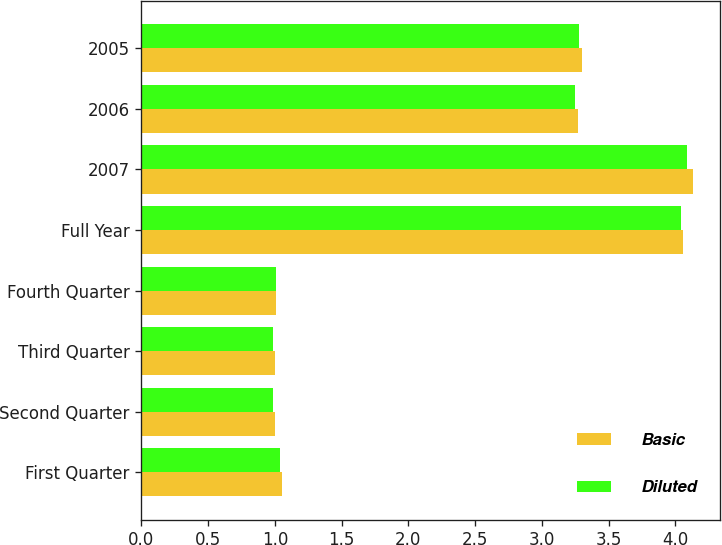<chart> <loc_0><loc_0><loc_500><loc_500><stacked_bar_chart><ecel><fcel>First Quarter<fcel>Second Quarter<fcel>Third Quarter<fcel>Fourth Quarter<fcel>Full Year<fcel>2007<fcel>2006<fcel>2005<nl><fcel>Basic<fcel>1.05<fcel>1<fcel>1<fcel>1.01<fcel>4.06<fcel>4.13<fcel>3.27<fcel>3.3<nl><fcel>Diluted<fcel>1.04<fcel>0.99<fcel>0.99<fcel>1.01<fcel>4.04<fcel>4.09<fcel>3.25<fcel>3.28<nl></chart> 